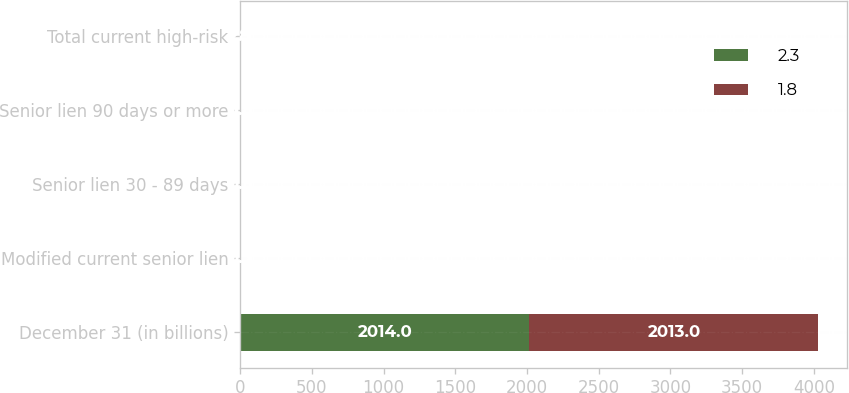<chart> <loc_0><loc_0><loc_500><loc_500><stacked_bar_chart><ecel><fcel>December 31 (in billions)<fcel>Modified current senior lien<fcel>Senior lien 30 - 89 days<fcel>Senior lien 90 days or more<fcel>Total current high-risk<nl><fcel>2.3<fcel>2014<fcel>0.7<fcel>0.5<fcel>0.6<fcel>1.8<nl><fcel>1.8<fcel>2013<fcel>0.9<fcel>0.6<fcel>0.8<fcel>2.3<nl></chart> 